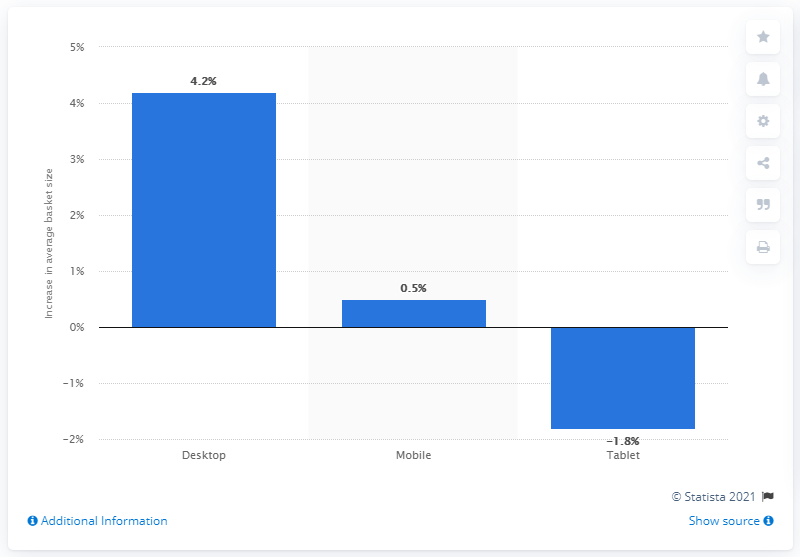What does this data suggest about consumer preferences in 2016? The data suggests that in 2016, consumers showed a stronger preference for desktop computers, as indicated by the largest growth percentage among the devices. There was also a marginal increase in mobile device usage, implying a steady or slightly growing interest. In contrast, the decrease in tablet usage could reflect a shift away from these devices in favor of alternatives like desktops or mobile phones. 